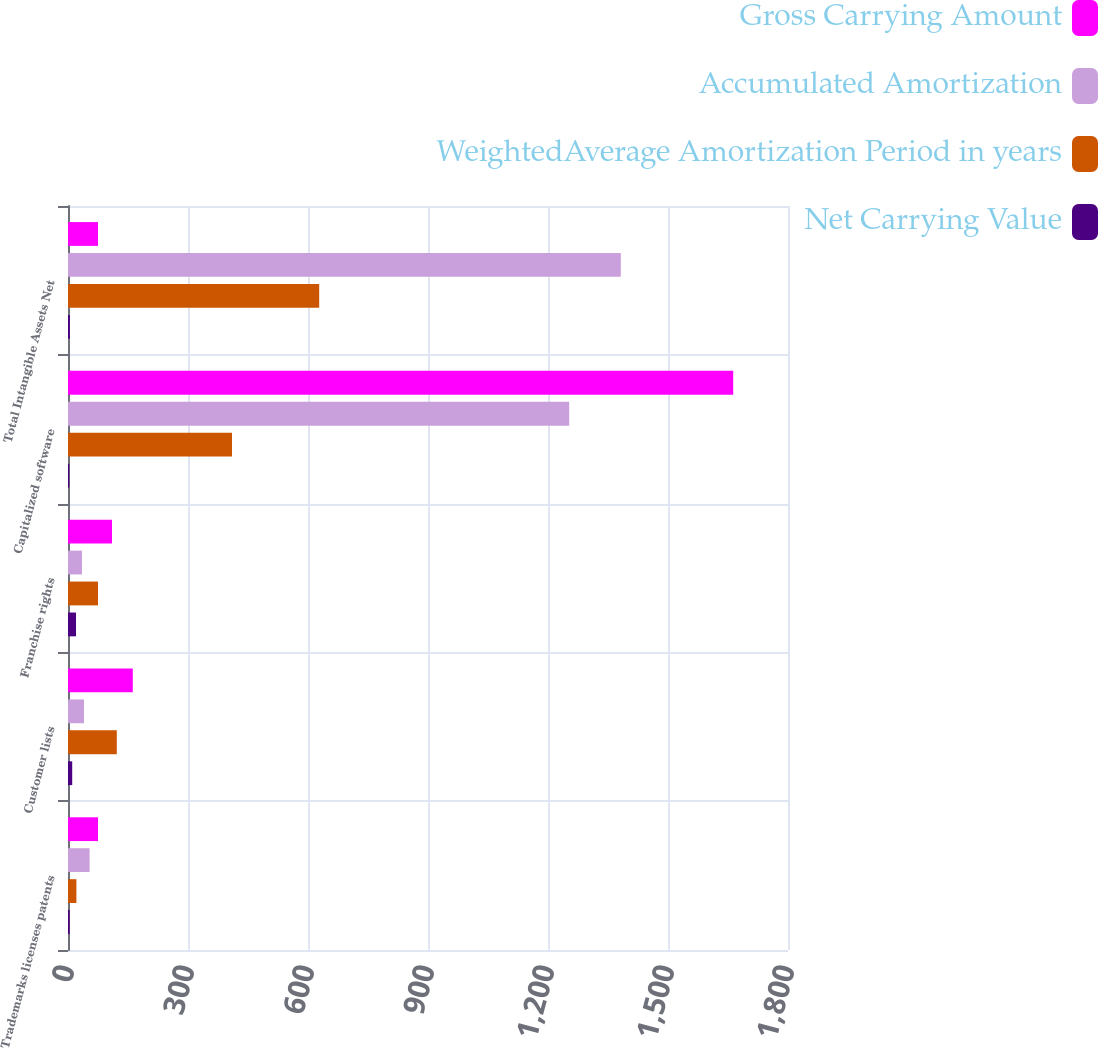Convert chart. <chart><loc_0><loc_0><loc_500><loc_500><stacked_bar_chart><ecel><fcel>Trademarks licenses patents<fcel>Customer lists<fcel>Franchise rights<fcel>Capitalized software<fcel>Total Intangible Assets Net<nl><fcel>Gross Carrying Amount<fcel>75<fcel>162<fcel>110<fcel>1663<fcel>75<nl><fcel>Accumulated Amortization<fcel>54<fcel>40<fcel>35<fcel>1253<fcel>1382<nl><fcel>WeightedAverage Amortization Period in years<fcel>21<fcel>122<fcel>75<fcel>410<fcel>628<nl><fcel>Net Carrying Value<fcel>4.2<fcel>10.5<fcel>20<fcel>3.2<fcel>4.7<nl></chart> 